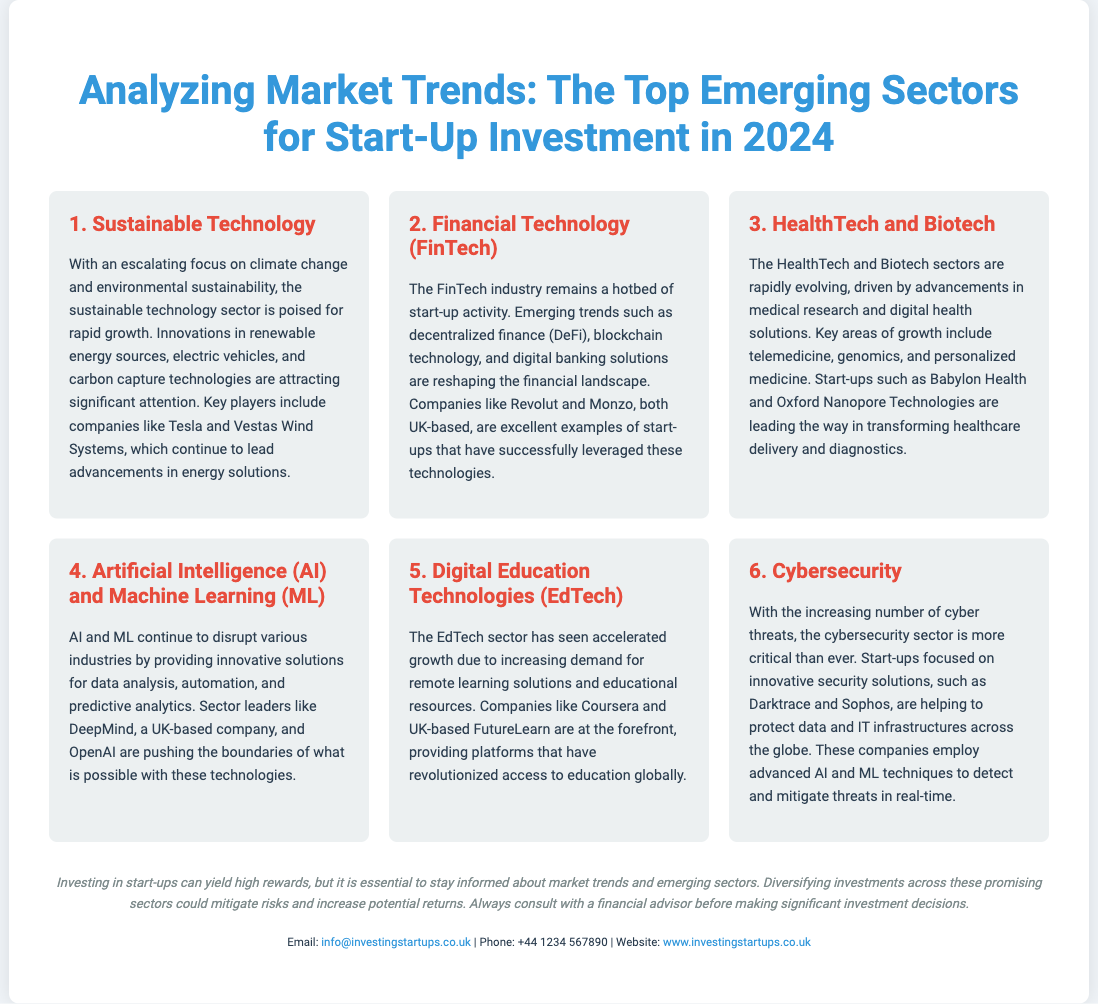What is the title of the poster? The title is prominently displayed at the top of the poster, indicating the poster's content and focus.
Answer: Analyzing Market Trends: The Top Emerging Sectors for Start-Up Investment in 2024 Which sector focuses on climate change and environmental sustainability? This sector is identified as having significant growth potential and is focused on innovations related to the environment.
Answer: Sustainable Technology Name one UK-based FinTech company mentioned in the document. The document lists specific companies that are examples in the FinTech industry, highlighting UK-based options.
Answer: Revolut What sector includes telemedicine and genomics? This sector is clearly defined in the context of advancements in healthcare and biotechnology solutions.
Answer: HealthTech and Biotech Which sector is described as critical due to increasing cyber threats? This question looks for the sector identified as essential in the current technological landscape due to rising risks.
Answer: Cybersecurity What type of technology do companies in the AI and ML sector focus on? This question targets the specific focus area of innovations in this emerging sector according to the document.
Answer: Data analysis, automation, and predictive analytics How many sectors are listed in the poster? The total number of sectors is displayed explicitly in the organization of the poster.
Answer: Six What is the purpose of diversifying investments across emerging sectors? The document suggests a particular strategy for managing investment risks effectively.
Answer: Mitigate risks and increase potential returns 